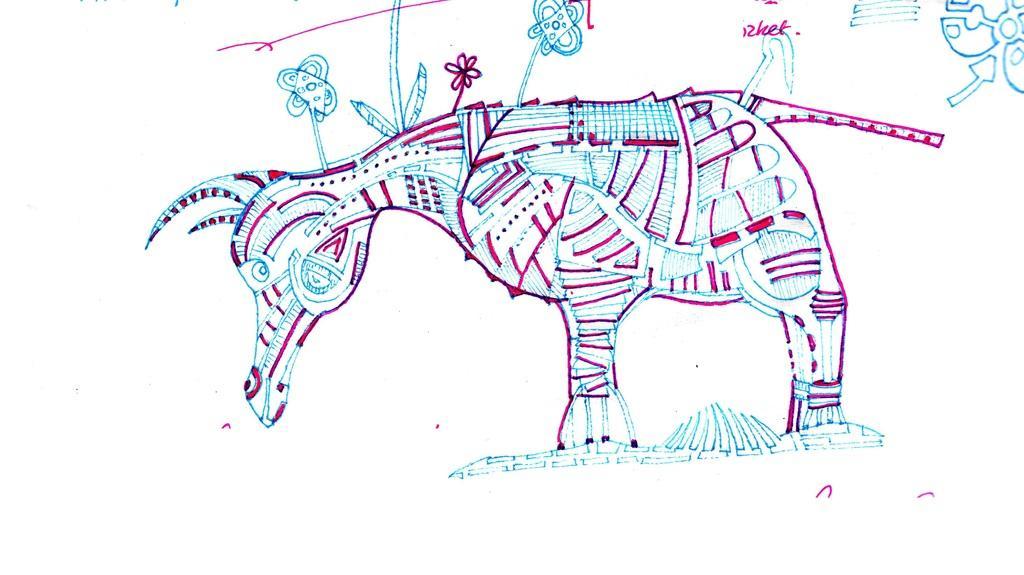Please provide a concise description of this image. This is a drawing of an animal. 